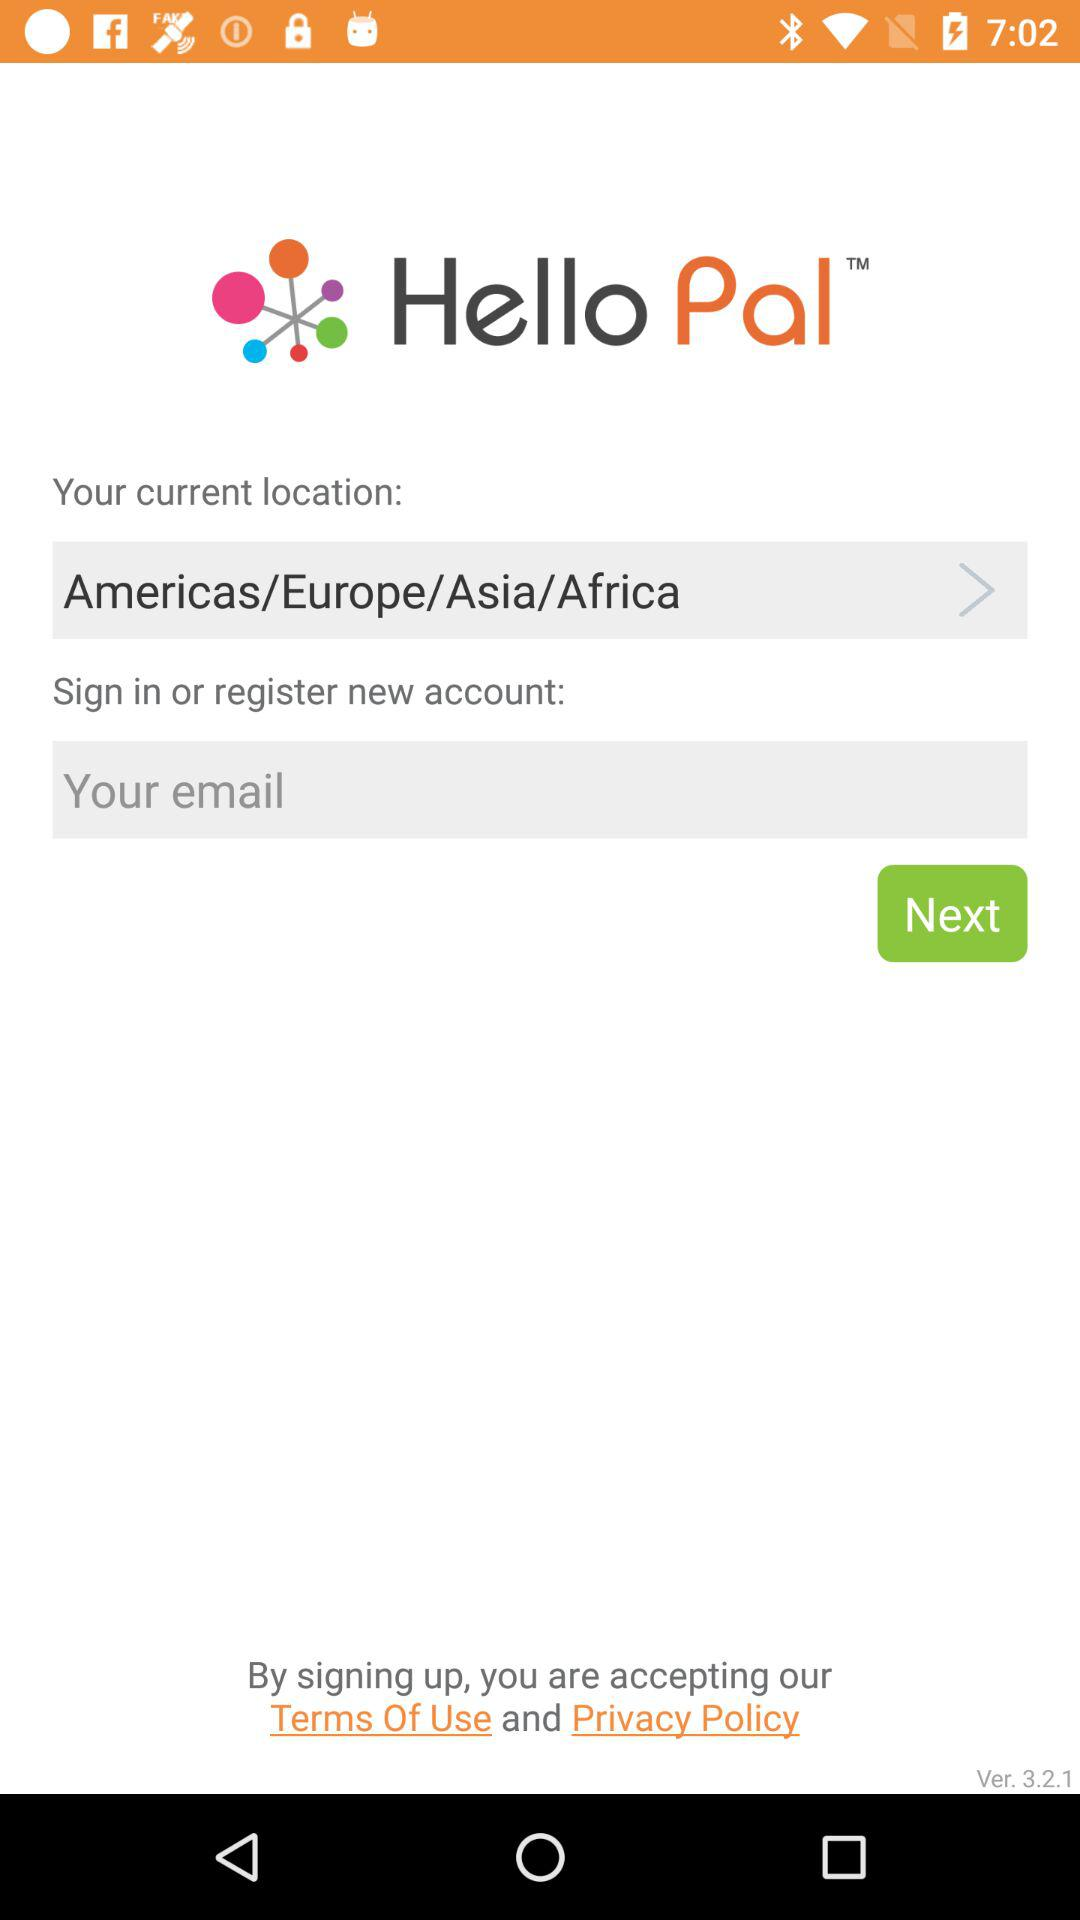What is the current location? The current location is "Americas/Europe/Asia/Africa". 